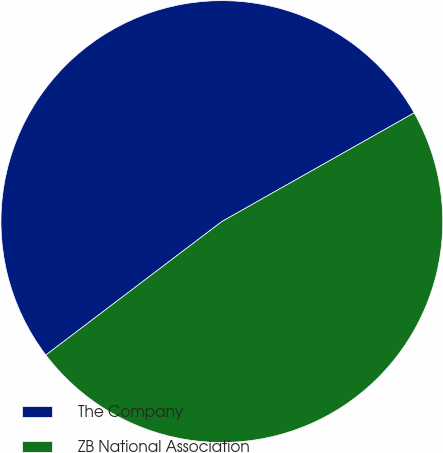Convert chart. <chart><loc_0><loc_0><loc_500><loc_500><pie_chart><fcel>The Company<fcel>ZB National Association<nl><fcel>52.14%<fcel>47.86%<nl></chart> 